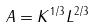Convert formula to latex. <formula><loc_0><loc_0><loc_500><loc_500>A = K ^ { 1 / 3 } L ^ { 2 / 3 }</formula> 